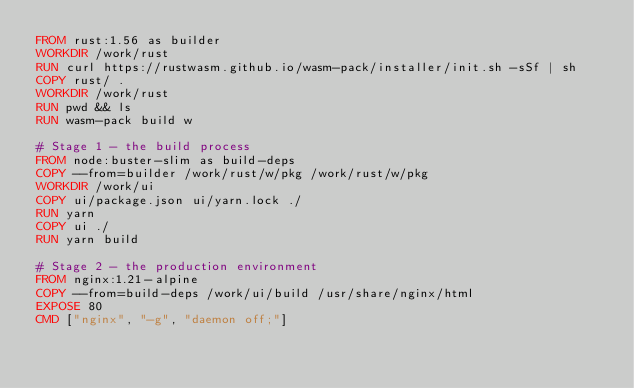Convert code to text. <code><loc_0><loc_0><loc_500><loc_500><_Dockerfile_>FROM rust:1.56 as builder
WORKDIR /work/rust
RUN curl https://rustwasm.github.io/wasm-pack/installer/init.sh -sSf | sh
COPY rust/ .
WORKDIR /work/rust
RUN pwd && ls
RUN wasm-pack build w

# Stage 1 - the build process
FROM node:buster-slim as build-deps
COPY --from=builder /work/rust/w/pkg /work/rust/w/pkg
WORKDIR /work/ui
COPY ui/package.json ui/yarn.lock ./
RUN yarn
COPY ui ./
RUN yarn build

# Stage 2 - the production environment
FROM nginx:1.21-alpine
COPY --from=build-deps /work/ui/build /usr/share/nginx/html
EXPOSE 80
CMD ["nginx", "-g", "daemon off;"]</code> 